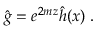<formula> <loc_0><loc_0><loc_500><loc_500>\hat { g } = e ^ { 2 m z } \hat { h } ( x ) \, .</formula> 